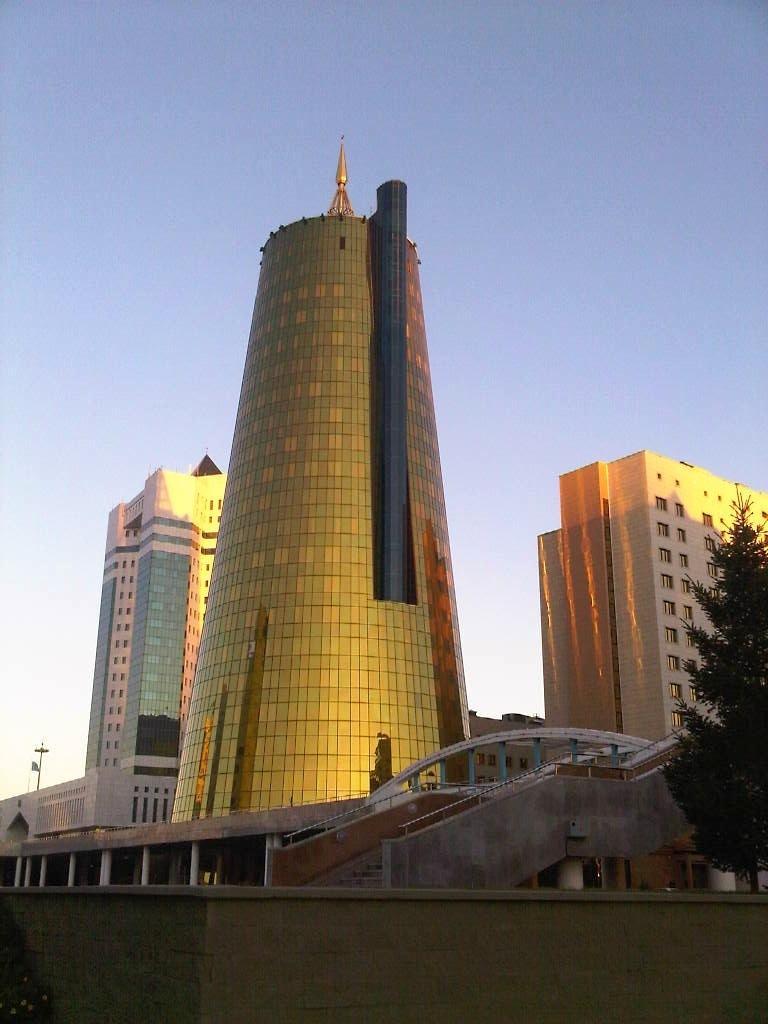How would you summarize this image in a sentence or two? In this picture we can see the buildings, tower, pole, flag, windows, stairs, tree, pillars. At the bottom of the image we can see the wall. At the top of the image we can see the sky. 